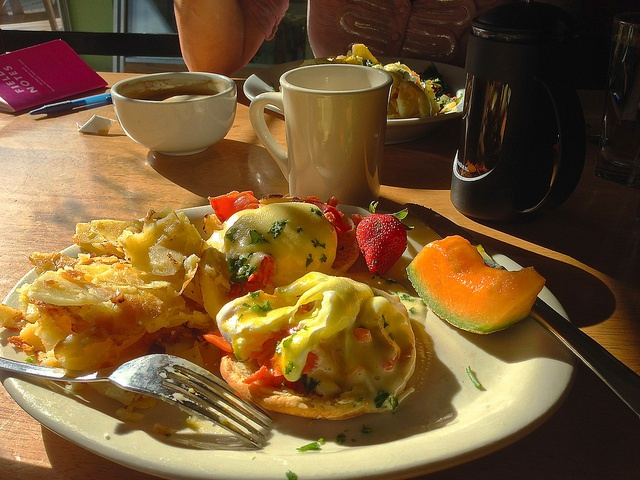Describe the objects in this image and their specific colors. I can see dining table in black, maroon, olive, and khaki tones, sandwich in maroon and olive tones, cup in maroon, black, and gray tones, cup in maroon and olive tones, and people in maroon, black, and brown tones in this image. 